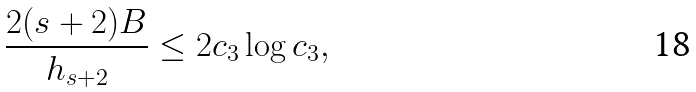Convert formula to latex. <formula><loc_0><loc_0><loc_500><loc_500>\frac { 2 ( s + 2 ) B } { h _ { s + 2 } } \leq 2 c _ { 3 } \log c _ { 3 } ,</formula> 